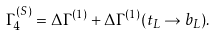Convert formula to latex. <formula><loc_0><loc_0><loc_500><loc_500>\Gamma _ { 4 } ^ { ( S ) } = \Delta \Gamma ^ { ( 1 ) } + \Delta \Gamma ^ { ( 1 ) } ( t _ { L } \rightarrow b _ { L } ) .</formula> 